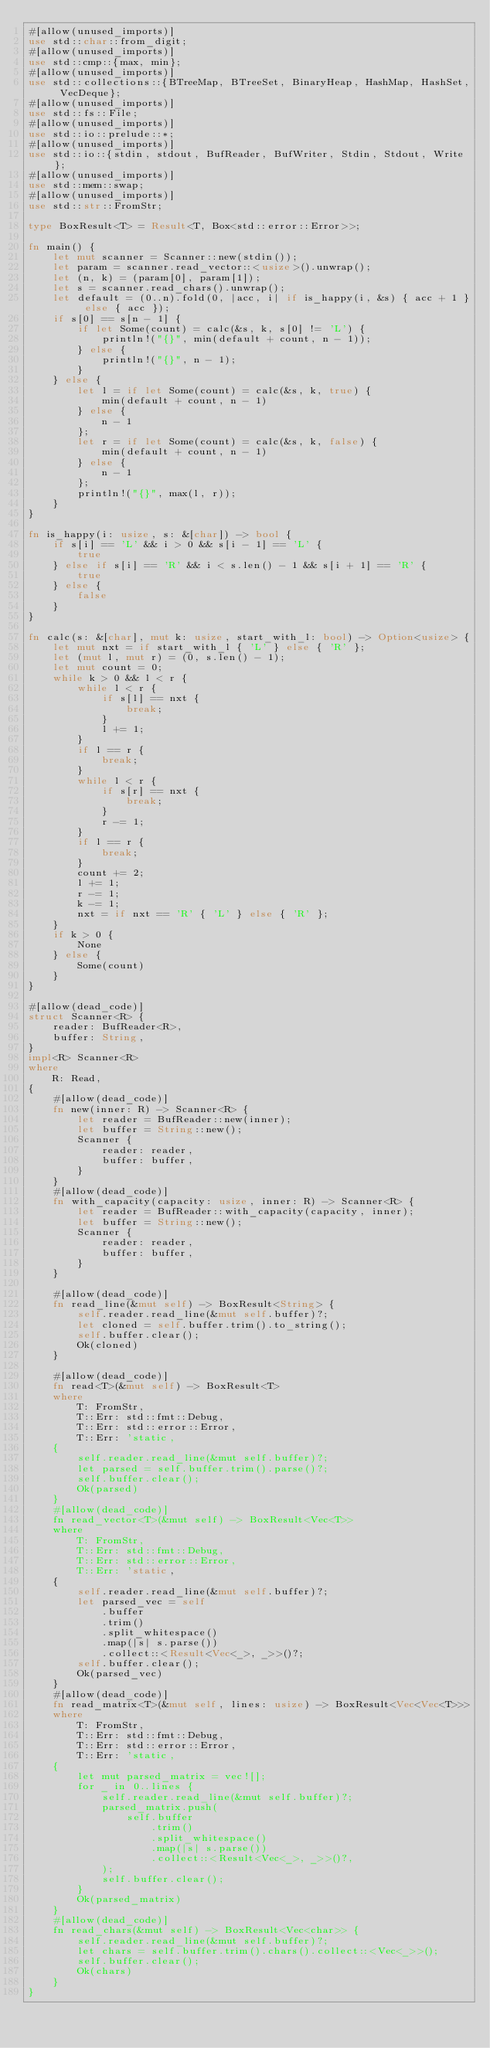<code> <loc_0><loc_0><loc_500><loc_500><_Rust_>#[allow(unused_imports)]
use std::char::from_digit;
#[allow(unused_imports)]
use std::cmp::{max, min};
#[allow(unused_imports)]
use std::collections::{BTreeMap, BTreeSet, BinaryHeap, HashMap, HashSet, VecDeque};
#[allow(unused_imports)]
use std::fs::File;
#[allow(unused_imports)]
use std::io::prelude::*;
#[allow(unused_imports)]
use std::io::{stdin, stdout, BufReader, BufWriter, Stdin, Stdout, Write};
#[allow(unused_imports)]
use std::mem::swap;
#[allow(unused_imports)]
use std::str::FromStr;

type BoxResult<T> = Result<T, Box<std::error::Error>>;

fn main() {
    let mut scanner = Scanner::new(stdin());
    let param = scanner.read_vector::<usize>().unwrap();
    let (n, k) = (param[0], param[1]);
    let s = scanner.read_chars().unwrap();
    let default = (0..n).fold(0, |acc, i| if is_happy(i, &s) { acc + 1 } else { acc });
    if s[0] == s[n - 1] {
        if let Some(count) = calc(&s, k, s[0] != 'L') {
            println!("{}", min(default + count, n - 1));
        } else {
            println!("{}", n - 1);
        }
    } else {
        let l = if let Some(count) = calc(&s, k, true) {
            min(default + count, n - 1)
        } else {
            n - 1
        };
        let r = if let Some(count) = calc(&s, k, false) {
            min(default + count, n - 1)
        } else {
            n - 1
        };
        println!("{}", max(l, r));
    }
}

fn is_happy(i: usize, s: &[char]) -> bool {
    if s[i] == 'L' && i > 0 && s[i - 1] == 'L' {
        true
    } else if s[i] == 'R' && i < s.len() - 1 && s[i + 1] == 'R' {
        true
    } else {
        false
    }
}

fn calc(s: &[char], mut k: usize, start_with_l: bool) -> Option<usize> {
    let mut nxt = if start_with_l { 'L' } else { 'R' };
    let (mut l, mut r) = (0, s.len() - 1);
    let mut count = 0;
    while k > 0 && l < r {
        while l < r {
            if s[l] == nxt {
                break;
            }
            l += 1;
        }
        if l == r {
            break;
        }
        while l < r {
            if s[r] == nxt {
                break;
            }
            r -= 1;
        }
        if l == r {
            break;
        }
        count += 2;
        l += 1;
        r -= 1;
        k -= 1;
        nxt = if nxt == 'R' { 'L' } else { 'R' };
    }
    if k > 0 {
        None
    } else {
        Some(count)
    }
}

#[allow(dead_code)]
struct Scanner<R> {
    reader: BufReader<R>,
    buffer: String,
}
impl<R> Scanner<R>
where
    R: Read,
{
    #[allow(dead_code)]
    fn new(inner: R) -> Scanner<R> {
        let reader = BufReader::new(inner);
        let buffer = String::new();
        Scanner {
            reader: reader,
            buffer: buffer,
        }
    }
    #[allow(dead_code)]
    fn with_capacity(capacity: usize, inner: R) -> Scanner<R> {
        let reader = BufReader::with_capacity(capacity, inner);
        let buffer = String::new();
        Scanner {
            reader: reader,
            buffer: buffer,
        }
    }

    #[allow(dead_code)]
    fn read_line(&mut self) -> BoxResult<String> {
        self.reader.read_line(&mut self.buffer)?;
        let cloned = self.buffer.trim().to_string();
        self.buffer.clear();
        Ok(cloned)
    }

    #[allow(dead_code)]
    fn read<T>(&mut self) -> BoxResult<T>
    where
        T: FromStr,
        T::Err: std::fmt::Debug,
        T::Err: std::error::Error,
        T::Err: 'static,
    {
        self.reader.read_line(&mut self.buffer)?;
        let parsed = self.buffer.trim().parse()?;
        self.buffer.clear();
        Ok(parsed)
    }
    #[allow(dead_code)]
    fn read_vector<T>(&mut self) -> BoxResult<Vec<T>>
    where
        T: FromStr,
        T::Err: std::fmt::Debug,
        T::Err: std::error::Error,
        T::Err: 'static,
    {
        self.reader.read_line(&mut self.buffer)?;
        let parsed_vec = self
            .buffer
            .trim()
            .split_whitespace()
            .map(|s| s.parse())
            .collect::<Result<Vec<_>, _>>()?;
        self.buffer.clear();
        Ok(parsed_vec)
    }
    #[allow(dead_code)]
    fn read_matrix<T>(&mut self, lines: usize) -> BoxResult<Vec<Vec<T>>>
    where
        T: FromStr,
        T::Err: std::fmt::Debug,
        T::Err: std::error::Error,
        T::Err: 'static,
    {
        let mut parsed_matrix = vec![];
        for _ in 0..lines {
            self.reader.read_line(&mut self.buffer)?;
            parsed_matrix.push(
                self.buffer
                    .trim()
                    .split_whitespace()
                    .map(|s| s.parse())
                    .collect::<Result<Vec<_>, _>>()?,
            );
            self.buffer.clear();
        }
        Ok(parsed_matrix)
    }
    #[allow(dead_code)]
    fn read_chars(&mut self) -> BoxResult<Vec<char>> {
        self.reader.read_line(&mut self.buffer)?;
        let chars = self.buffer.trim().chars().collect::<Vec<_>>();
        self.buffer.clear();
        Ok(chars)
    }
}
</code> 